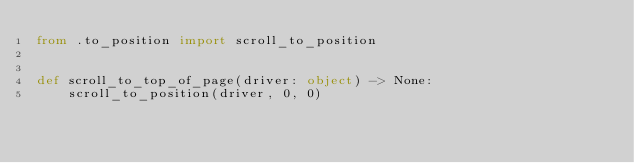<code> <loc_0><loc_0><loc_500><loc_500><_Python_>from .to_position import scroll_to_position


def scroll_to_top_of_page(driver: object) -> None:
    scroll_to_position(driver, 0, 0)
</code> 